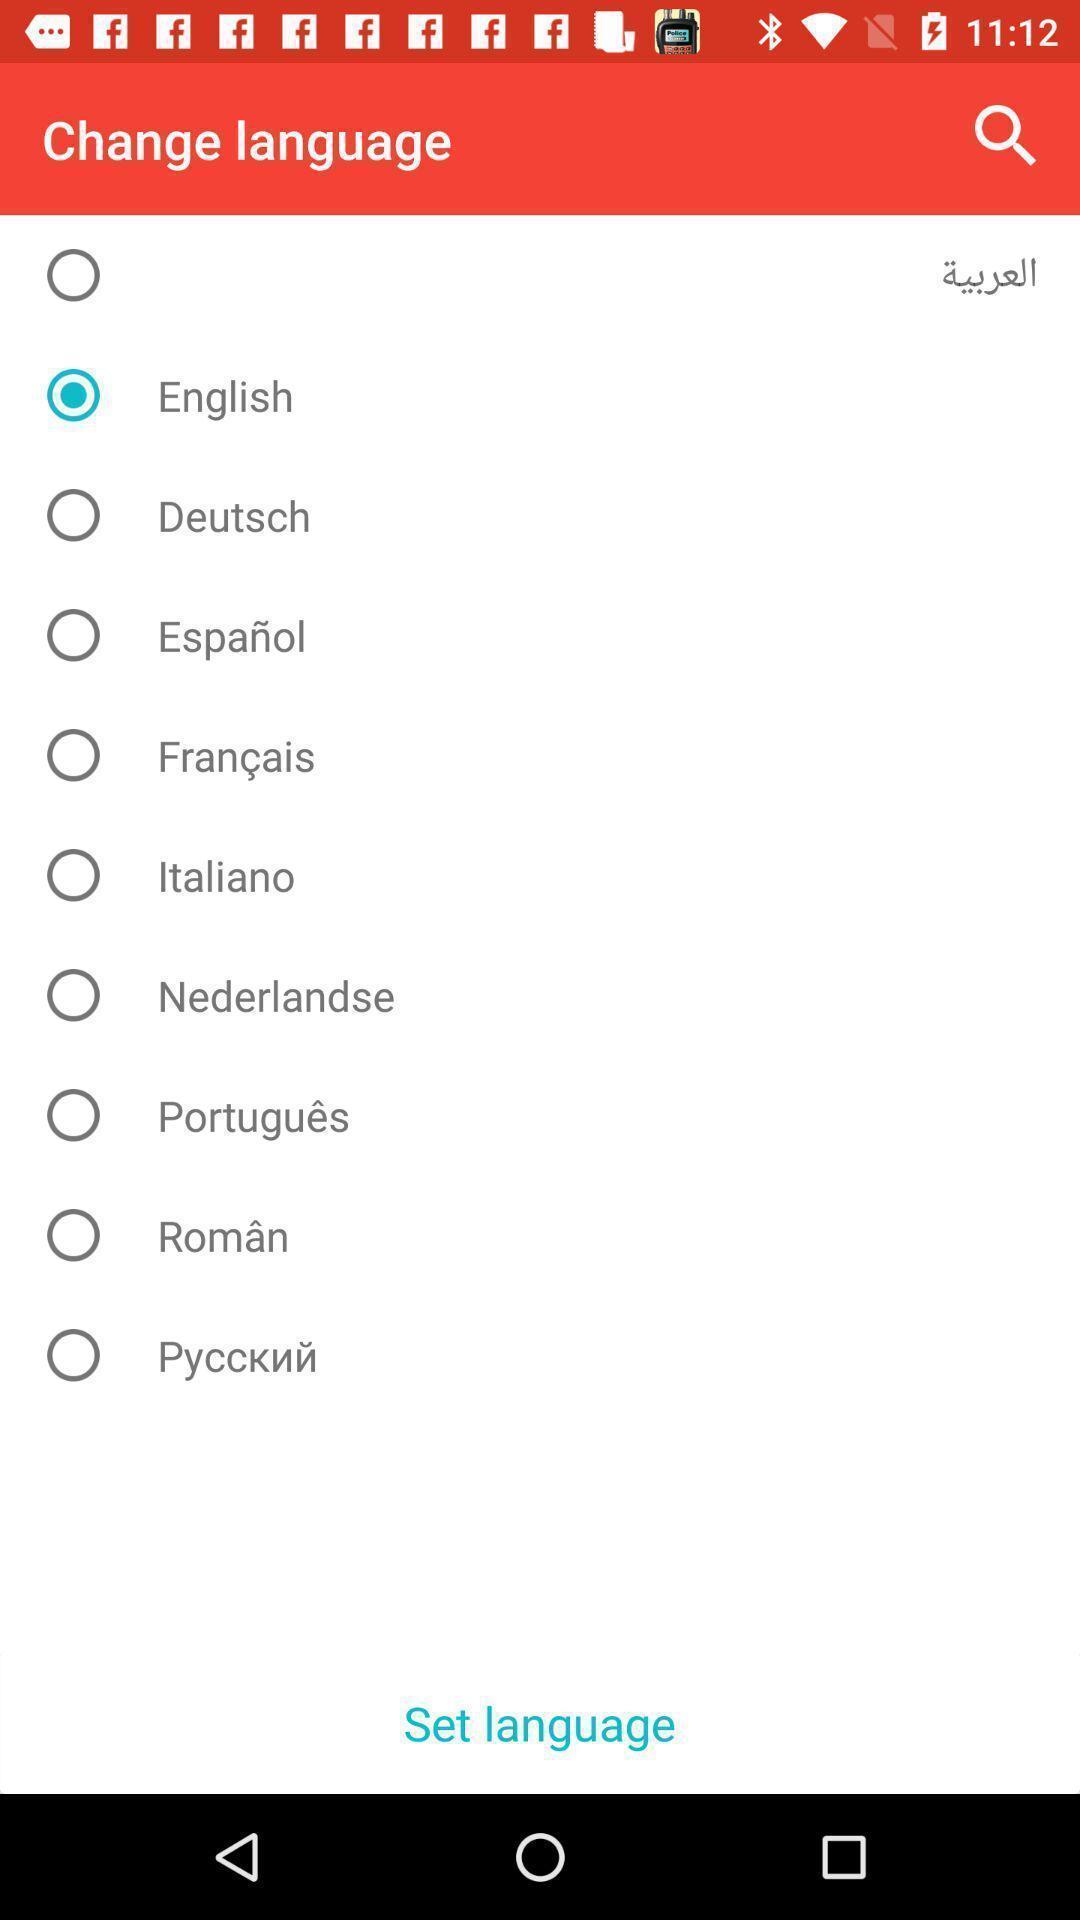Explain what's happening in this screen capture. Page displaying to choose language among them. 